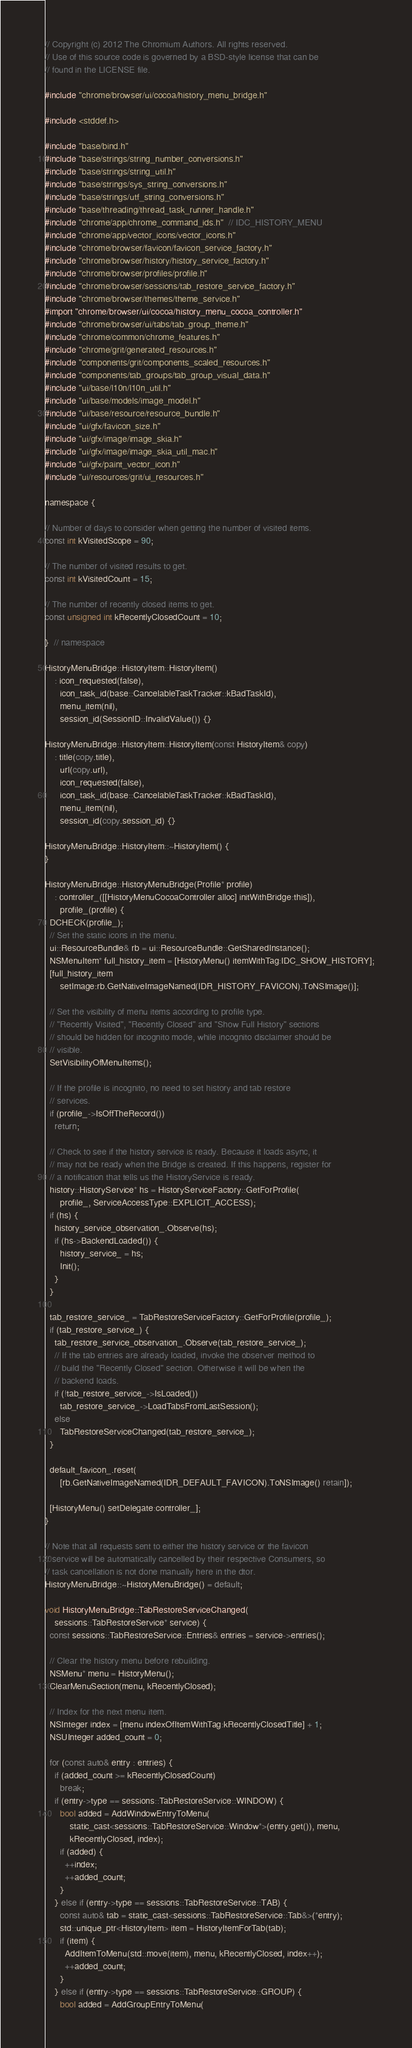<code> <loc_0><loc_0><loc_500><loc_500><_ObjectiveC_>// Copyright (c) 2012 The Chromium Authors. All rights reserved.
// Use of this source code is governed by a BSD-style license that can be
// found in the LICENSE file.

#include "chrome/browser/ui/cocoa/history_menu_bridge.h"

#include <stddef.h>

#include "base/bind.h"
#include "base/strings/string_number_conversions.h"
#include "base/strings/string_util.h"
#include "base/strings/sys_string_conversions.h"
#include "base/strings/utf_string_conversions.h"
#include "base/threading/thread_task_runner_handle.h"
#include "chrome/app/chrome_command_ids.h"  // IDC_HISTORY_MENU
#include "chrome/app/vector_icons/vector_icons.h"
#include "chrome/browser/favicon/favicon_service_factory.h"
#include "chrome/browser/history/history_service_factory.h"
#include "chrome/browser/profiles/profile.h"
#include "chrome/browser/sessions/tab_restore_service_factory.h"
#include "chrome/browser/themes/theme_service.h"
#import "chrome/browser/ui/cocoa/history_menu_cocoa_controller.h"
#include "chrome/browser/ui/tabs/tab_group_theme.h"
#include "chrome/common/chrome_features.h"
#include "chrome/grit/generated_resources.h"
#include "components/grit/components_scaled_resources.h"
#include "components/tab_groups/tab_group_visual_data.h"
#include "ui/base/l10n/l10n_util.h"
#include "ui/base/models/image_model.h"
#include "ui/base/resource/resource_bundle.h"
#include "ui/gfx/favicon_size.h"
#include "ui/gfx/image/image_skia.h"
#include "ui/gfx/image/image_skia_util_mac.h"
#include "ui/gfx/paint_vector_icon.h"
#include "ui/resources/grit/ui_resources.h"

namespace {

// Number of days to consider when getting the number of visited items.
const int kVisitedScope = 90;

// The number of visited results to get.
const int kVisitedCount = 15;

// The number of recently closed items to get.
const unsigned int kRecentlyClosedCount = 10;

}  // namespace

HistoryMenuBridge::HistoryItem::HistoryItem()
    : icon_requested(false),
      icon_task_id(base::CancelableTaskTracker::kBadTaskId),
      menu_item(nil),
      session_id(SessionID::InvalidValue()) {}

HistoryMenuBridge::HistoryItem::HistoryItem(const HistoryItem& copy)
    : title(copy.title),
      url(copy.url),
      icon_requested(false),
      icon_task_id(base::CancelableTaskTracker::kBadTaskId),
      menu_item(nil),
      session_id(copy.session_id) {}

HistoryMenuBridge::HistoryItem::~HistoryItem() {
}

HistoryMenuBridge::HistoryMenuBridge(Profile* profile)
    : controller_([[HistoryMenuCocoaController alloc] initWithBridge:this]),
      profile_(profile) {
  DCHECK(profile_);
  // Set the static icons in the menu.
  ui::ResourceBundle& rb = ui::ResourceBundle::GetSharedInstance();
  NSMenuItem* full_history_item = [HistoryMenu() itemWithTag:IDC_SHOW_HISTORY];
  [full_history_item
      setImage:rb.GetNativeImageNamed(IDR_HISTORY_FAVICON).ToNSImage()];

  // Set the visibility of menu items according to profile type.
  // "Recently Visited", "Recently Closed" and "Show Full History" sections
  // should be hidden for incognito mode, while incognito disclaimer should be
  // visible.
  SetVisibilityOfMenuItems();

  // If the profile is incognito, no need to set history and tab restore
  // services.
  if (profile_->IsOffTheRecord())
    return;

  // Check to see if the history service is ready. Because it loads async, it
  // may not be ready when the Bridge is created. If this happens, register for
  // a notification that tells us the HistoryService is ready.
  history::HistoryService* hs = HistoryServiceFactory::GetForProfile(
      profile_, ServiceAccessType::EXPLICIT_ACCESS);
  if (hs) {
    history_service_observation_.Observe(hs);
    if (hs->BackendLoaded()) {
      history_service_ = hs;
      Init();
    }
  }

  tab_restore_service_ = TabRestoreServiceFactory::GetForProfile(profile_);
  if (tab_restore_service_) {
    tab_restore_service_observation_.Observe(tab_restore_service_);
    // If the tab entries are already loaded, invoke the observer method to
    // build the "Recently Closed" section. Otherwise it will be when the
    // backend loads.
    if (!tab_restore_service_->IsLoaded())
      tab_restore_service_->LoadTabsFromLastSession();
    else
      TabRestoreServiceChanged(tab_restore_service_);
  }

  default_favicon_.reset(
      [rb.GetNativeImageNamed(IDR_DEFAULT_FAVICON).ToNSImage() retain]);

  [HistoryMenu() setDelegate:controller_];
}

// Note that all requests sent to either the history service or the favicon
// service will be automatically cancelled by their respective Consumers, so
// task cancellation is not done manually here in the dtor.
HistoryMenuBridge::~HistoryMenuBridge() = default;

void HistoryMenuBridge::TabRestoreServiceChanged(
    sessions::TabRestoreService* service) {
  const sessions::TabRestoreService::Entries& entries = service->entries();

  // Clear the history menu before rebuilding.
  NSMenu* menu = HistoryMenu();
  ClearMenuSection(menu, kRecentlyClosed);

  // Index for the next menu item.
  NSInteger index = [menu indexOfItemWithTag:kRecentlyClosedTitle] + 1;
  NSUInteger added_count = 0;

  for (const auto& entry : entries) {
    if (added_count >= kRecentlyClosedCount)
      break;
    if (entry->type == sessions::TabRestoreService::WINDOW) {
      bool added = AddWindowEntryToMenu(
          static_cast<sessions::TabRestoreService::Window*>(entry.get()), menu,
          kRecentlyClosed, index);
      if (added) {
        ++index;
        ++added_count;
      }
    } else if (entry->type == sessions::TabRestoreService::TAB) {
      const auto& tab = static_cast<sessions::TabRestoreService::Tab&>(*entry);
      std::unique_ptr<HistoryItem> item = HistoryItemForTab(tab);
      if (item) {
        AddItemToMenu(std::move(item), menu, kRecentlyClosed, index++);
        ++added_count;
      }
    } else if (entry->type == sessions::TabRestoreService::GROUP) {
      bool added = AddGroupEntryToMenu(</code> 